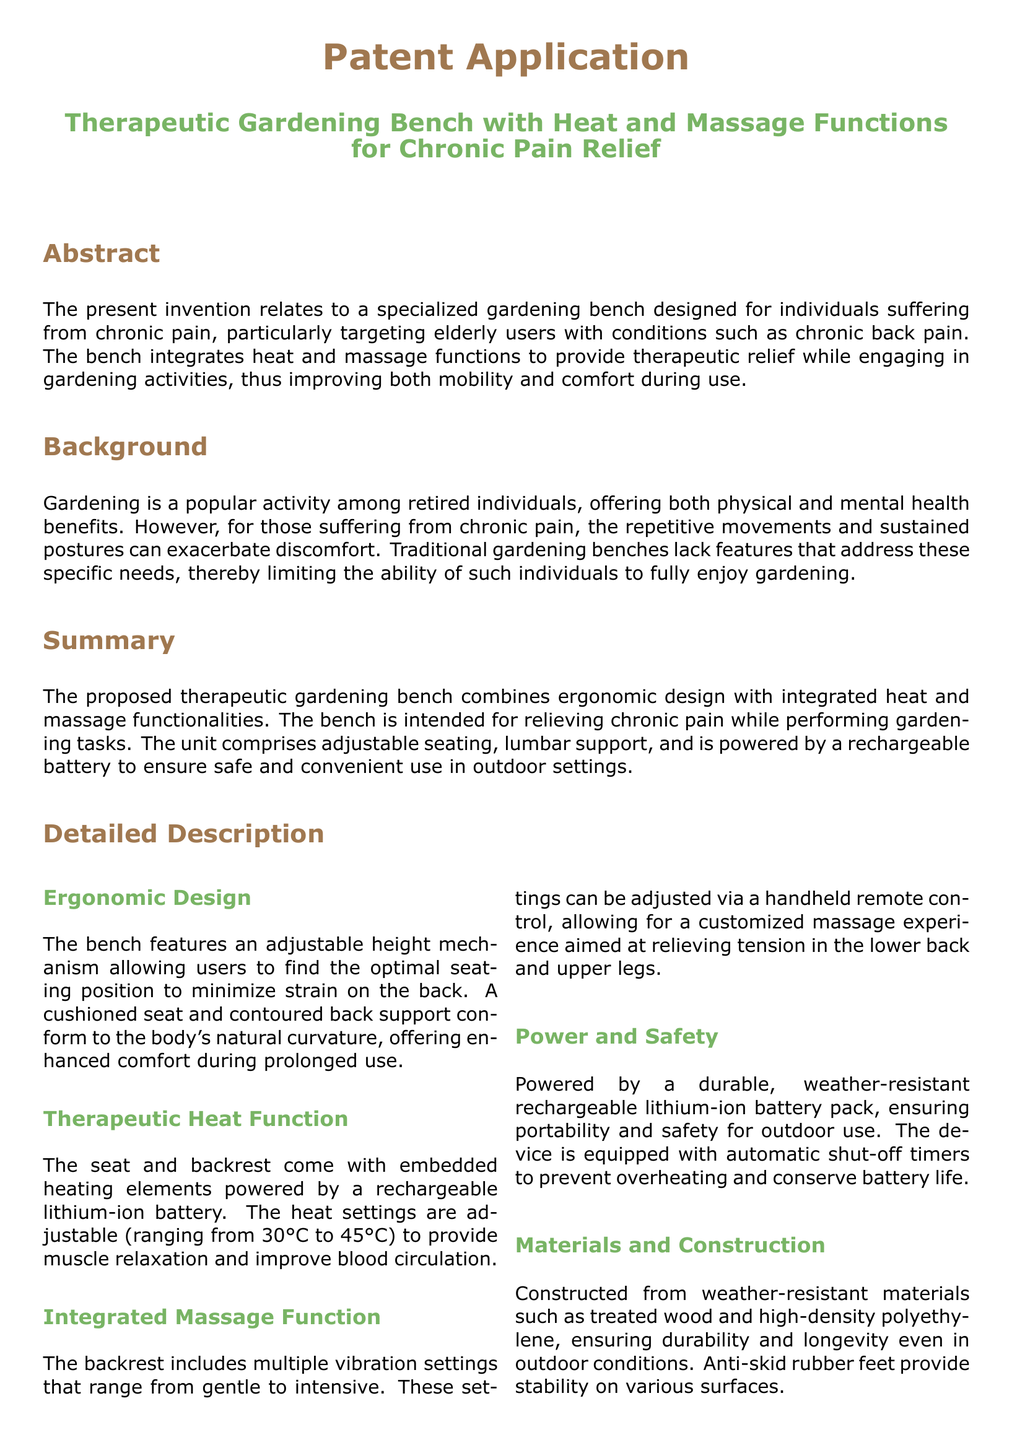What is the primary benefit of the therapeutic gardening bench? The primary benefit is providing therapeutic relief for individuals suffering from chronic pain while gardening.
Answer: therapeutic relief What are the adjustable temperature settings for the heat function? The heat settings are adjustable from 30°C to 45°C.
Answer: 30°C to 45°C What materials are used in the construction of the bench? The bench is constructed from weather-resistant materials such as treated wood and high-density polyethylene.
Answer: treated wood and high-density polyethylene How many vibration settings does the massage function include? The massage function includes multiple vibration settings ranging from gentle to intensive.
Answer: multiple What feature ensures the safety of the bench during use? Automatic shut-off timers help prevent overheating and conserve battery life.
Answer: automatic shut-off timers What is the power source for the bench? The bench is powered by a rechargeable lithium-ion battery pack.
Answer: rechargeable lithium-ion battery pack How is the bench's height adjusted? The bench features an adjustable height mechanism for optimal seating position.
Answer: adjustable height mechanism What specific conditions does the bench target? The bench specifically targets individuals suffering from chronic pain, particularly chronic back pain.
Answer: chronic back pain 